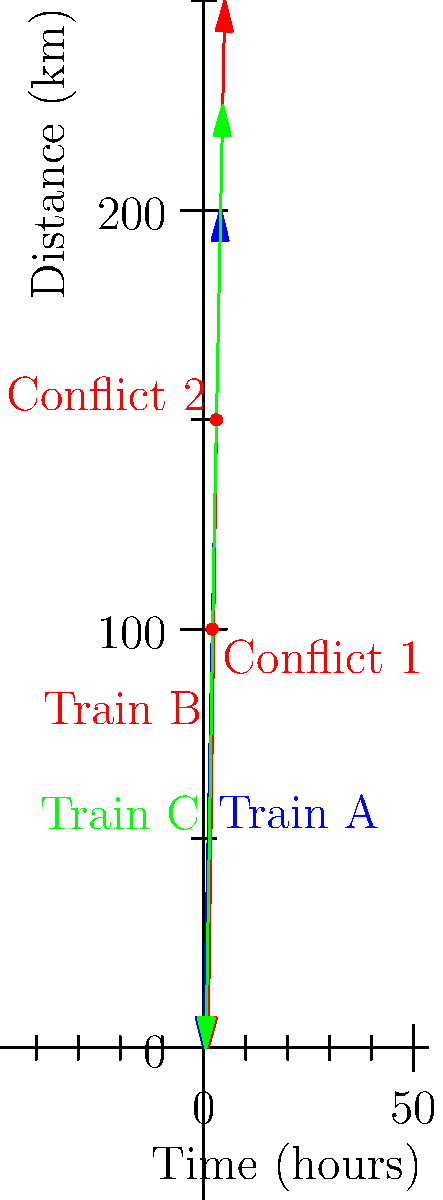As a locomotive engineer, you're tasked with optimizing the departure schedule for three trains (A, B, and C) to minimize conflicts on a single-track railway. The time-distance graph shows the current schedule, with two conflict points. If you can delay the departure of one train by up to 1 hour, which train should you delay and by how much to eliminate both conflicts while minimizing the total delay? To solve this optimization problem, let's analyze the conflicts and possible solutions step-by-step:

1. Identify the conflicts:
   - Conflict 1: Trains A and C at t = 2 hours, d = 100 km
   - Conflict 2: Trains B and C at t = 3 hours, d = 150 km

2. Analyze each train's schedule:
   - Train A: Departs at t = 0
   - Train B: Departs at t = 1
   - Train C: Departs at t = 0.5

3. Consider the options for delaying each train:
   a) Delaying Train A:
      - Would not resolve Conflict 1
      - Would not affect Conflict 2
      - Not a viable solution

   b) Delaying Train B:
      - Would not affect Conflict 1
      - Could resolve Conflict 2 if delayed by 1 hour
      - Partial solution, but doesn't resolve both conflicts

   c) Delaying Train C:
      - Could resolve both conflicts
      - Delaying by 0.5 hours would resolve Conflict 1
      - Delaying by 1 hour would resolve both Conflict 1 and Conflict 2

4. Optimal solution:
   - Delay Train C by 1 hour
   - This will shift Train C's path to start at t = 1.5
   - Both conflicts will be eliminated
   - The total delay is minimized at 1 hour

5. Verification:
   - New departure time for Train C: t = 1.5
   - Train C will now reach the first conflict point (100 km) at t = 3
   - Train C will reach the second conflict point (150 km) at t = 4
   - Both original conflicts are resolved with minimal total delay
Answer: Delay Train C by 1 hour. 